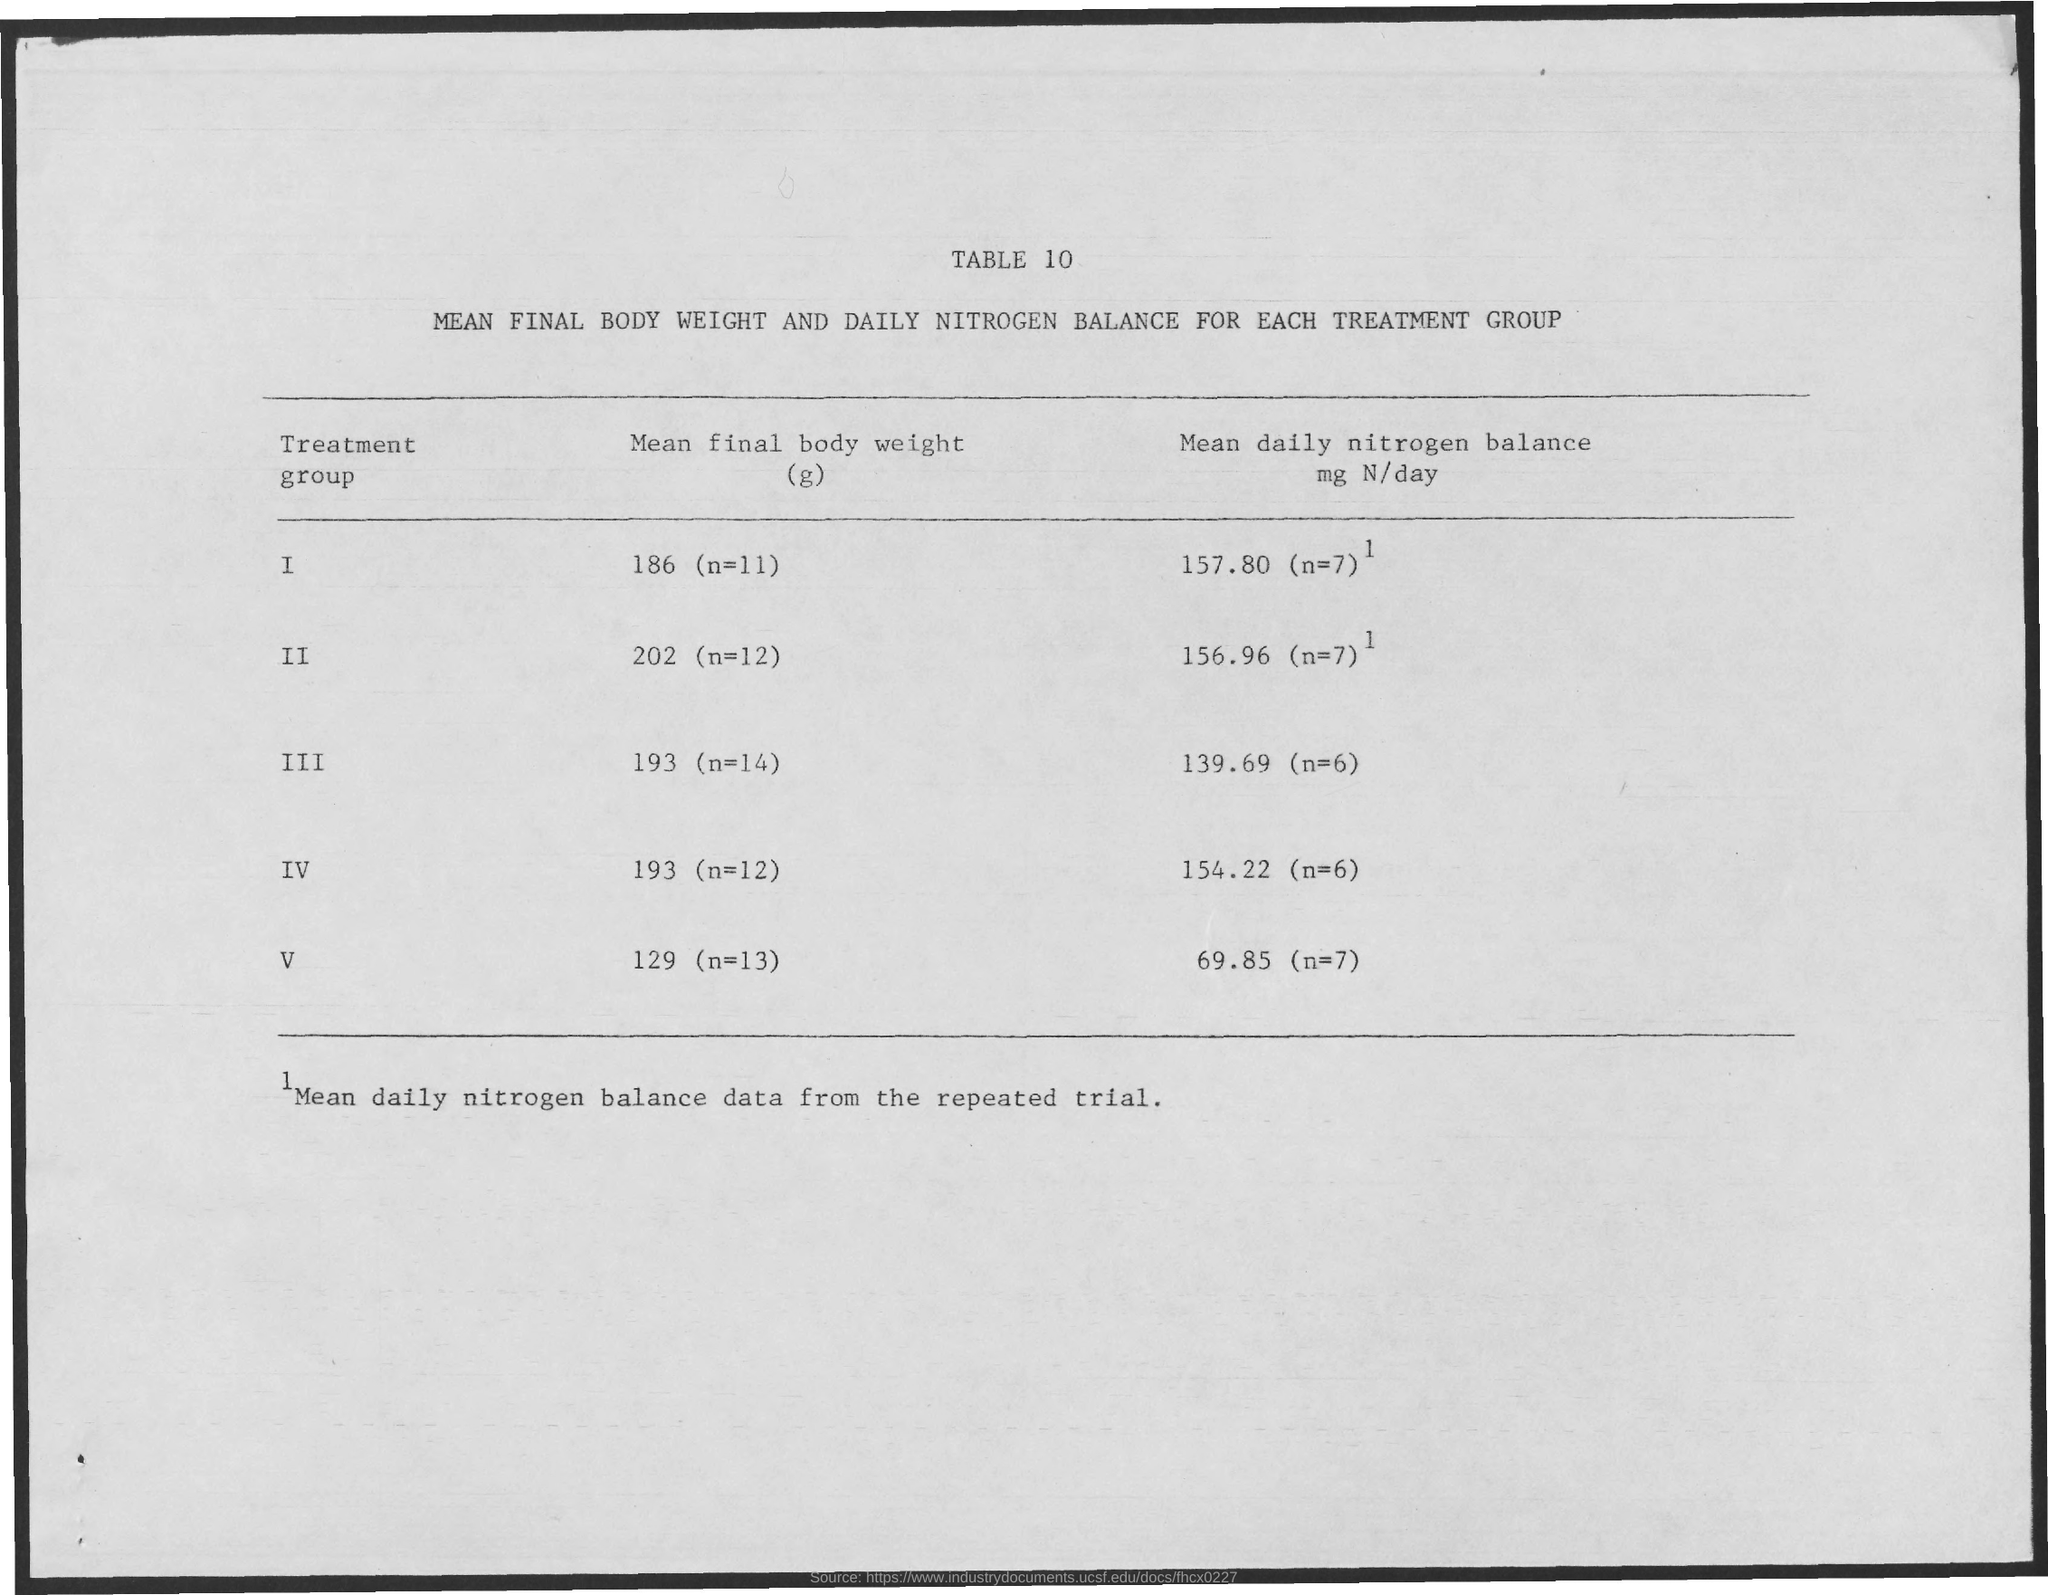Outline some significant characteristics in this image. The mean final body weight of treatment group one was 186 (n=11). 